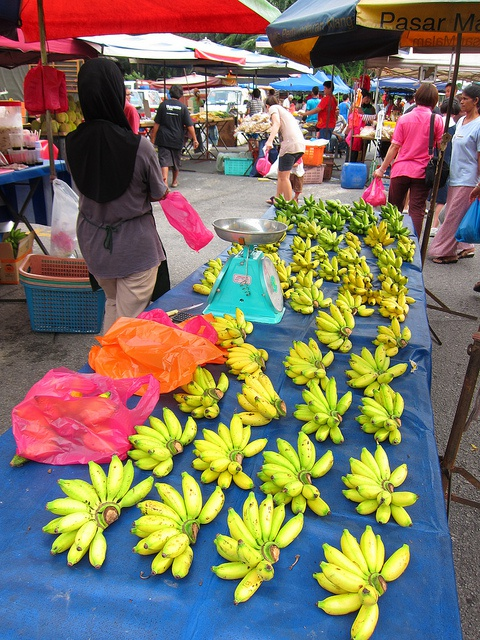Describe the objects in this image and their specific colors. I can see dining table in black, blue, yellow, and gray tones, people in black and gray tones, umbrella in black, maroon, and brown tones, umbrella in black, red, brown, and beige tones, and banana in black, yellow, and khaki tones in this image. 